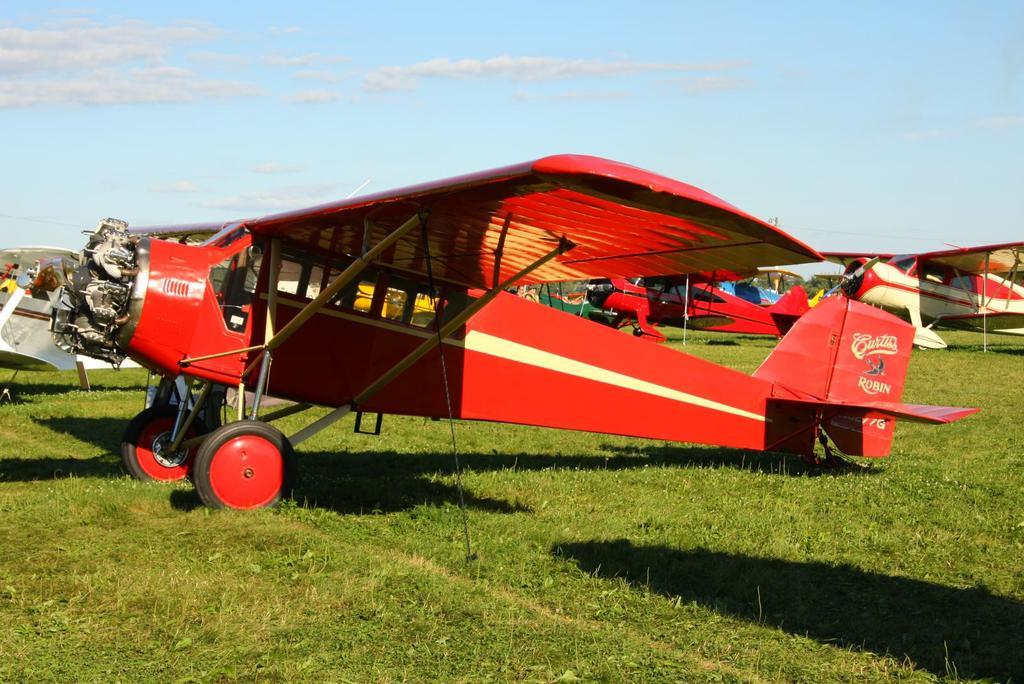What is the main subject of the image? The main subject of the image is jets. What is the condition of the land in the image? The land is covered with grass. How would you describe the sky in the image? The sky is cloudy in the image. What type of cup is being used to serve the yam in the image? There is no cup or yam present in the image; it features jets and a cloudy sky. 